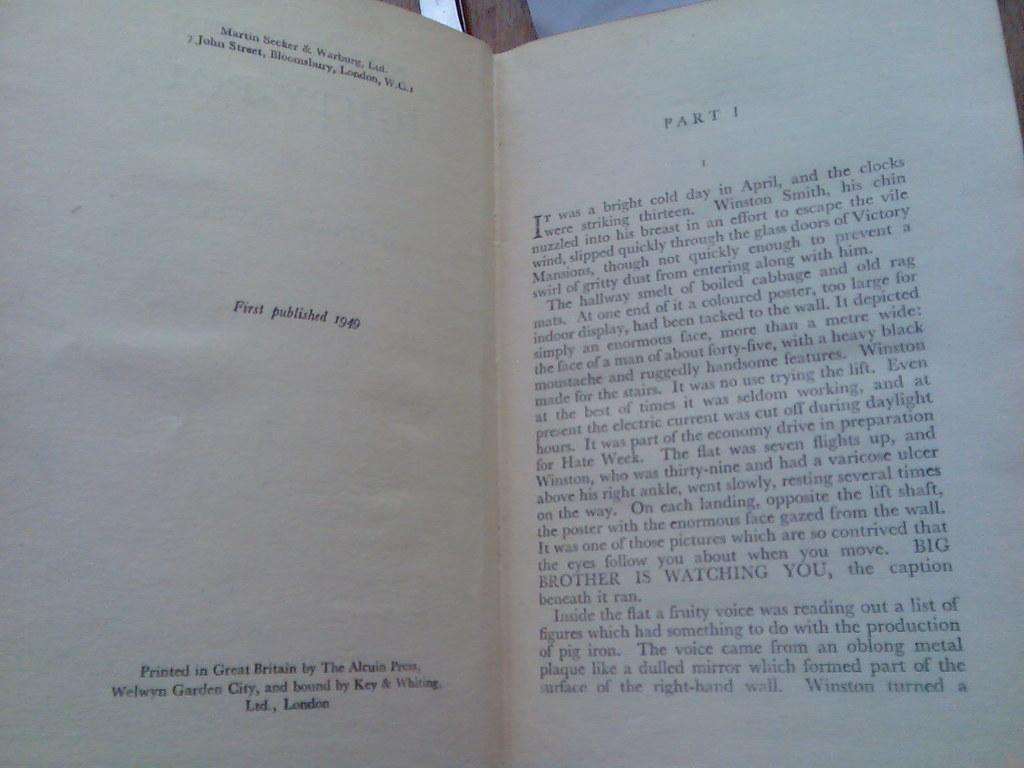<image>
Create a compact narrative representing the image presented. A book first published in 1949 is shown opened to part one. 